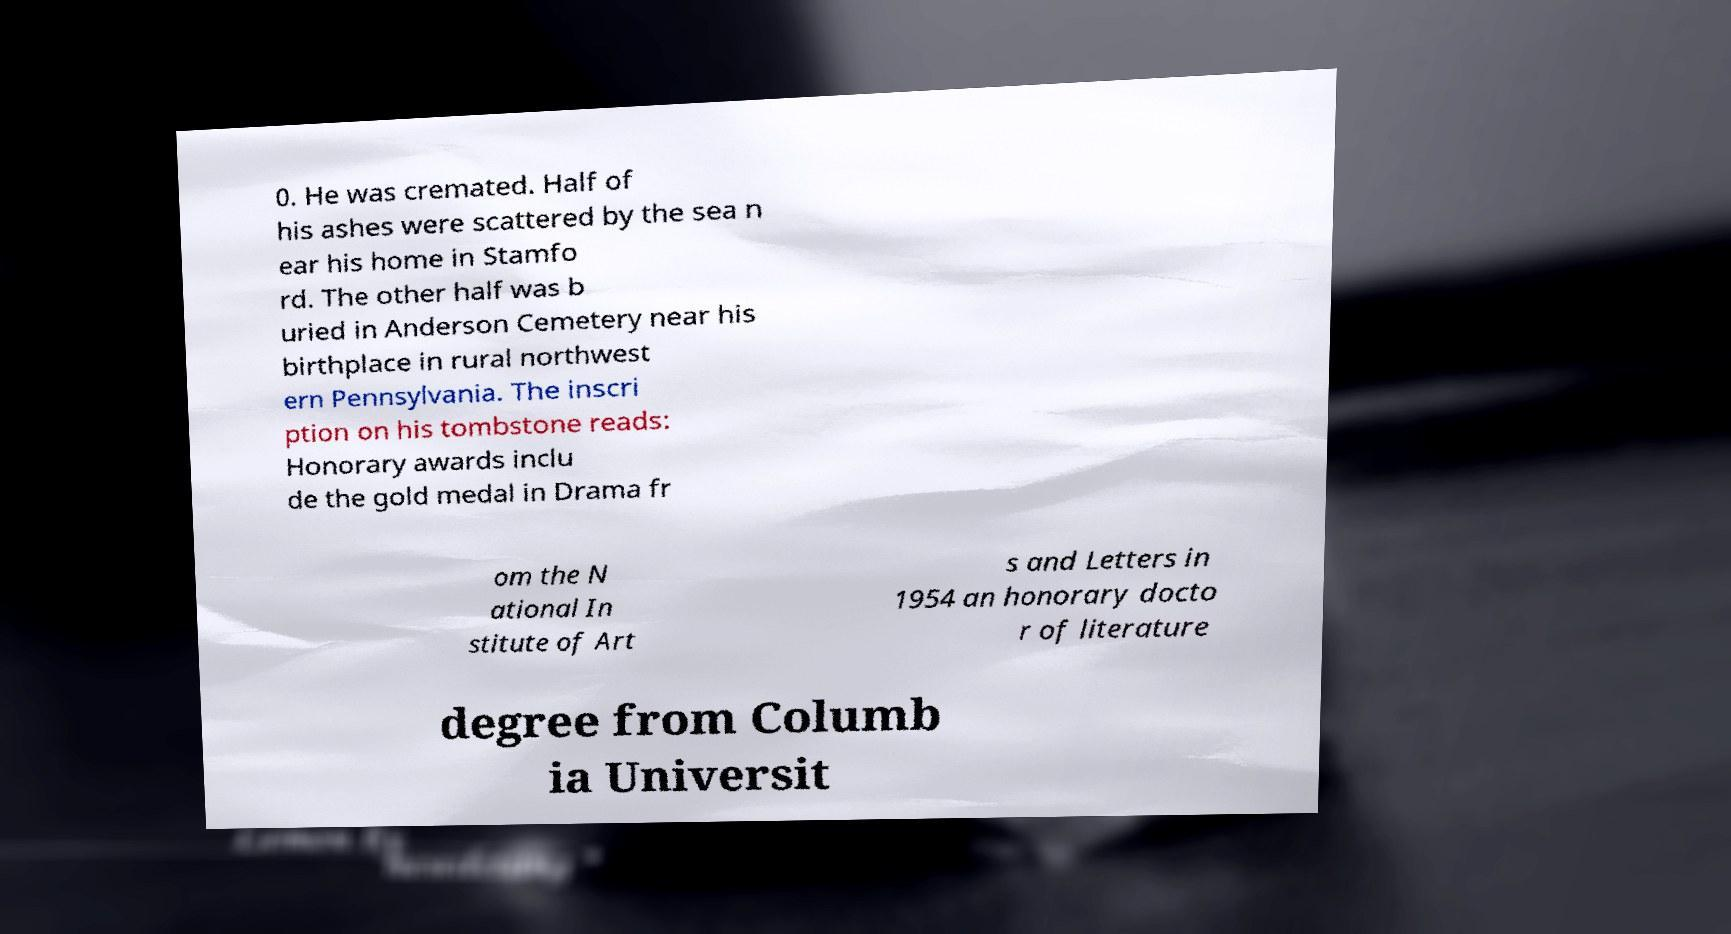I need the written content from this picture converted into text. Can you do that? 0. He was cremated. Half of his ashes were scattered by the sea n ear his home in Stamfo rd. The other half was b uried in Anderson Cemetery near his birthplace in rural northwest ern Pennsylvania. The inscri ption on his tombstone reads: Honorary awards inclu de the gold medal in Drama fr om the N ational In stitute of Art s and Letters in 1954 an honorary docto r of literature degree from Columb ia Universit 